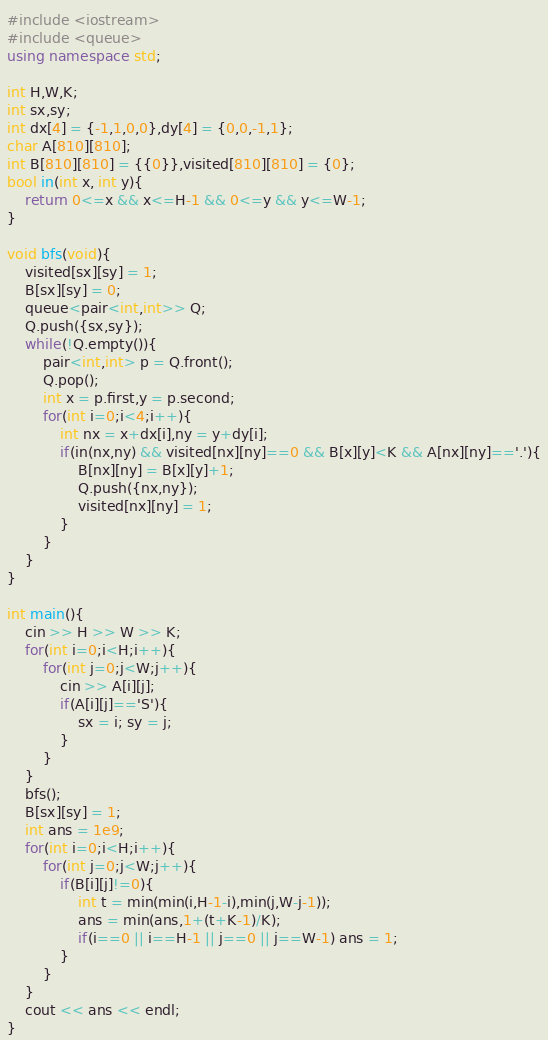<code> <loc_0><loc_0><loc_500><loc_500><_C++_>#include <iostream>
#include <queue>
using namespace std;

int H,W,K;
int sx,sy;
int dx[4] = {-1,1,0,0},dy[4] = {0,0,-1,1};
char A[810][810];
int B[810][810] = {{0}},visited[810][810] = {0};
bool in(int x, int y){
	return 0<=x && x<=H-1 && 0<=y && y<=W-1;
}

void bfs(void){
	visited[sx][sy] = 1;
	B[sx][sy] = 0;
	queue<pair<int,int>> Q;
	Q.push({sx,sy});
	while(!Q.empty()){
		pair<int,int> p = Q.front();
		Q.pop();
		int x = p.first,y = p.second;
		for(int i=0;i<4;i++){
			int nx = x+dx[i],ny = y+dy[i];
			if(in(nx,ny) && visited[nx][ny]==0 && B[x][y]<K && A[nx][ny]=='.'){
				B[nx][ny] = B[x][y]+1;
				Q.push({nx,ny});
				visited[nx][ny] = 1;
			}
		}
	}
}

int main(){
	cin >> H >> W >> K;
	for(int i=0;i<H;i++){
		for(int j=0;j<W;j++){
			cin >> A[i][j];
			if(A[i][j]=='S'){
				sx = i; sy = j;
			}
		}
	}
	bfs();
	B[sx][sy] = 1;
	int ans = 1e9;
	for(int i=0;i<H;i++){
		for(int j=0;j<W;j++){
			if(B[i][j]!=0){
				int t = min(min(i,H-1-i),min(j,W-j-1));
				ans = min(ans,1+(t+K-1)/K);
				if(i==0 || i==H-1 || j==0 || j==W-1) ans = 1;
			}
		}
	}
	cout << ans << endl;
}</code> 